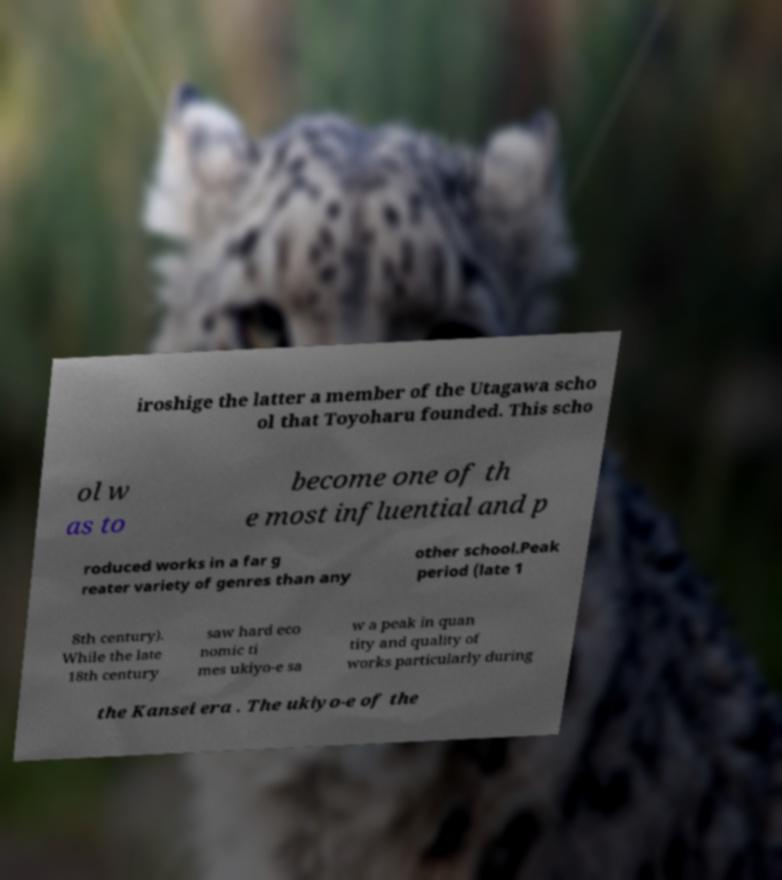I need the written content from this picture converted into text. Can you do that? iroshige the latter a member of the Utagawa scho ol that Toyoharu founded. This scho ol w as to become one of th e most influential and p roduced works in a far g reater variety of genres than any other school.Peak period (late 1 8th century). While the late 18th century saw hard eco nomic ti mes ukiyo-e sa w a peak in quan tity and quality of works particularly during the Kansei era . The ukiyo-e of the 